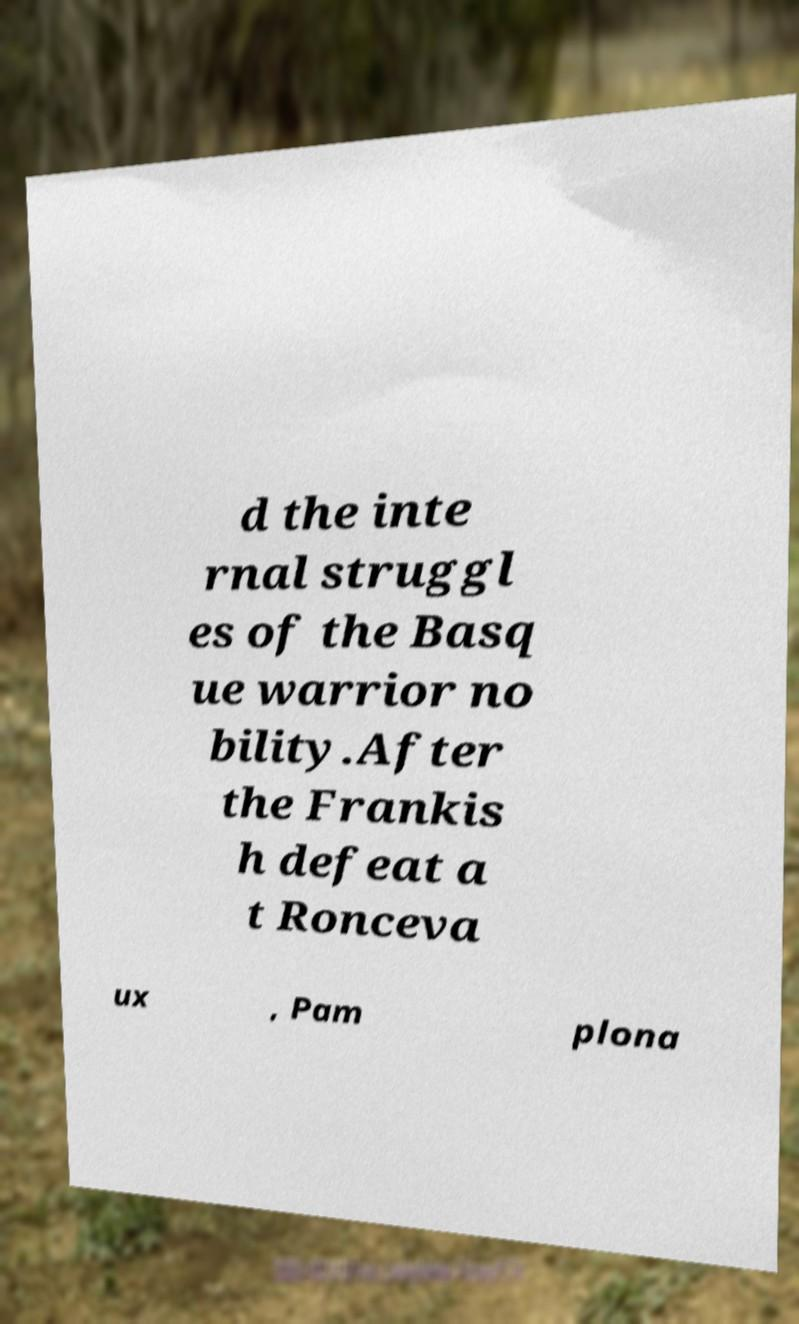Could you assist in decoding the text presented in this image and type it out clearly? d the inte rnal struggl es of the Basq ue warrior no bility.After the Frankis h defeat a t Ronceva ux , Pam plona 